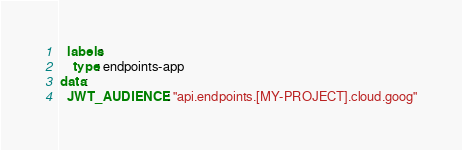Convert code to text. <code><loc_0><loc_0><loc_500><loc_500><_YAML_>  labels:
    type: endpoints-app
data:
  JWT_AUDIENCE: "api.endpoints.[MY-PROJECT].cloud.goog"</code> 